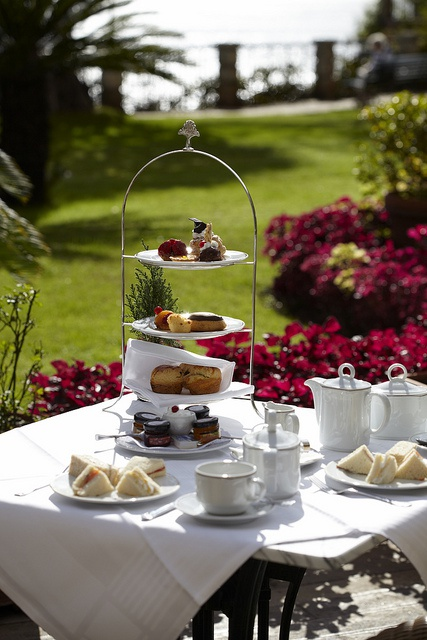Describe the objects in this image and their specific colors. I can see dining table in black, white, darkgray, and gray tones, cup in black, darkgray, lightgray, and gray tones, cup in black, darkgray, gray, and lightgray tones, cup in black, darkgray, lightgray, and gray tones, and bowl in black, darkgray, lightgray, and maroon tones in this image. 